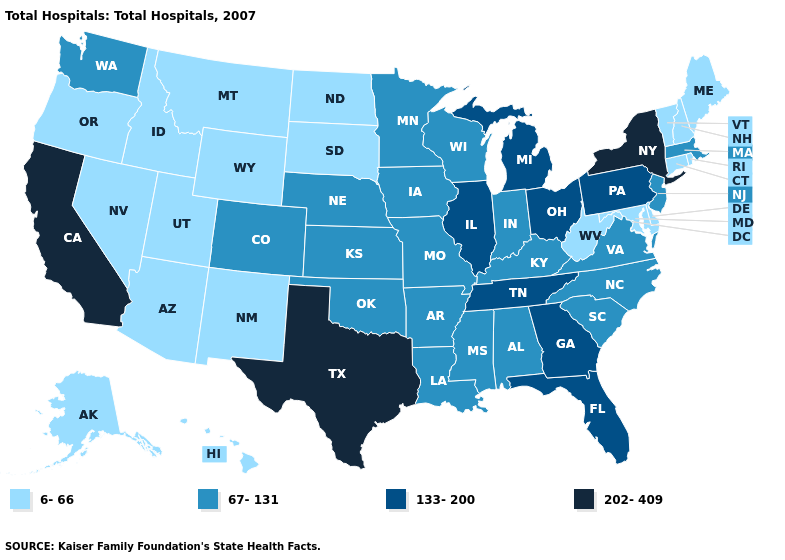Does Alaska have the highest value in the USA?
Quick response, please. No. Name the states that have a value in the range 133-200?
Short answer required. Florida, Georgia, Illinois, Michigan, Ohio, Pennsylvania, Tennessee. What is the lowest value in the USA?
Write a very short answer. 6-66. What is the lowest value in states that border Connecticut?
Short answer required. 6-66. Which states have the lowest value in the South?
Keep it brief. Delaware, Maryland, West Virginia. Name the states that have a value in the range 67-131?
Concise answer only. Alabama, Arkansas, Colorado, Indiana, Iowa, Kansas, Kentucky, Louisiana, Massachusetts, Minnesota, Mississippi, Missouri, Nebraska, New Jersey, North Carolina, Oklahoma, South Carolina, Virginia, Washington, Wisconsin. What is the value of Tennessee?
Be succinct. 133-200. Name the states that have a value in the range 6-66?
Answer briefly. Alaska, Arizona, Connecticut, Delaware, Hawaii, Idaho, Maine, Maryland, Montana, Nevada, New Hampshire, New Mexico, North Dakota, Oregon, Rhode Island, South Dakota, Utah, Vermont, West Virginia, Wyoming. Does Ohio have the lowest value in the MidWest?
Quick response, please. No. What is the value of Wisconsin?
Answer briefly. 67-131. What is the highest value in states that border Kentucky?
Give a very brief answer. 133-200. How many symbols are there in the legend?
Concise answer only. 4. What is the value of Oklahoma?
Give a very brief answer. 67-131. Name the states that have a value in the range 133-200?
Be succinct. Florida, Georgia, Illinois, Michigan, Ohio, Pennsylvania, Tennessee. Among the states that border Florida , does Georgia have the highest value?
Keep it brief. Yes. 